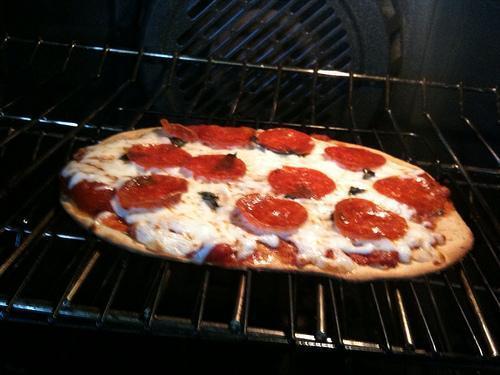How many pizzas are there?
Give a very brief answer. 1. How many ovens are there?
Give a very brief answer. 1. How many chairs are in this scene?
Give a very brief answer. 0. 